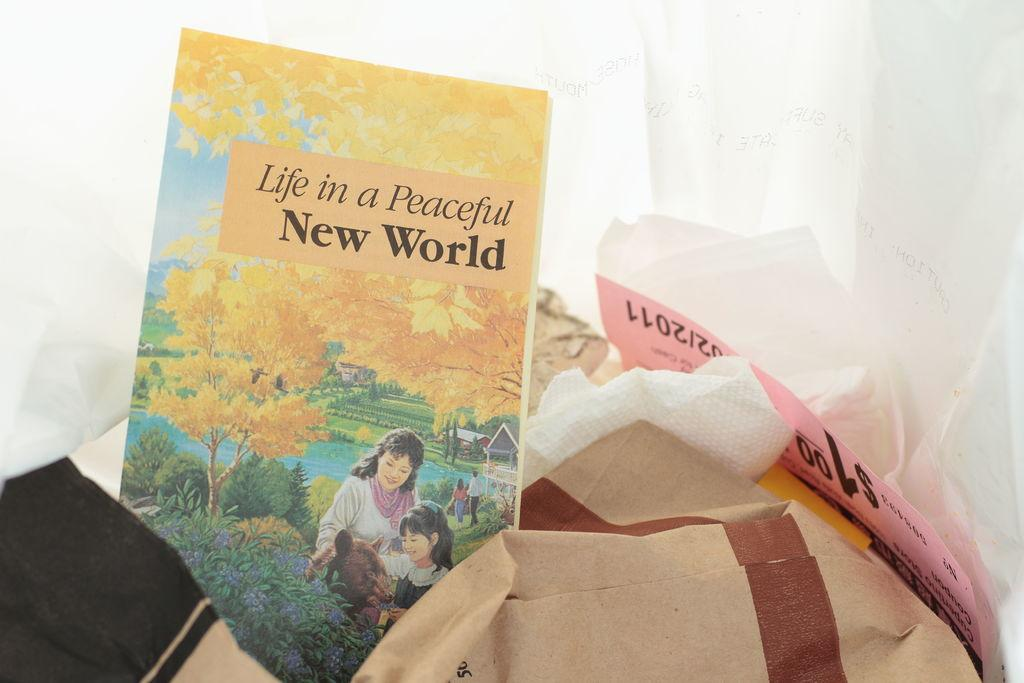<image>
Write a terse but informative summary of the picture. A book titled Life in a Peaceful New World shows a mother and daughter picking flowers on the cover 